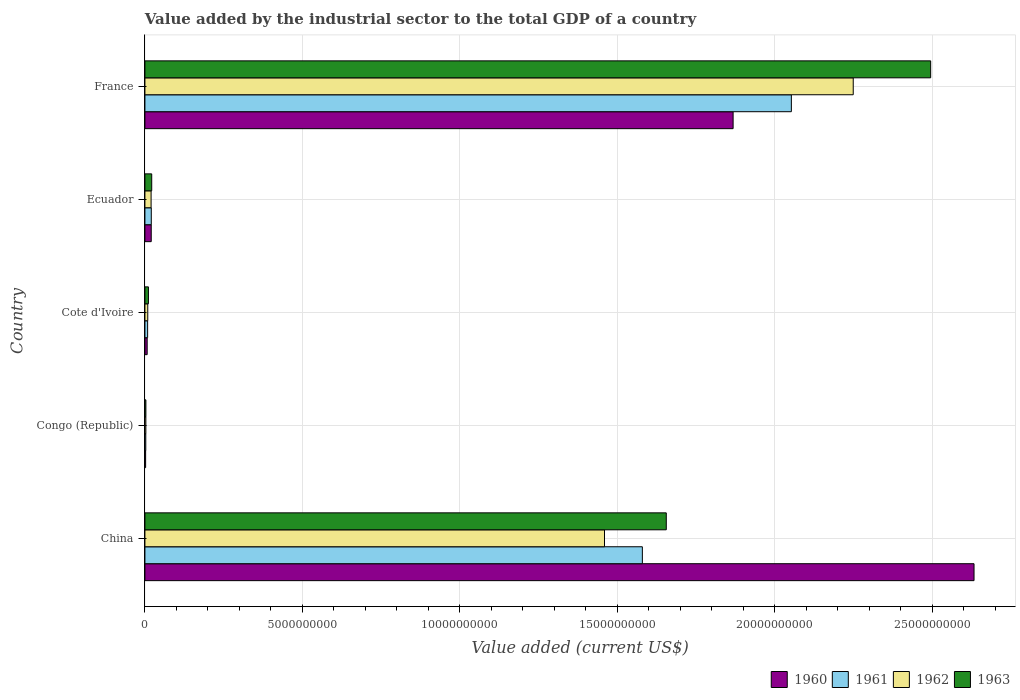How many different coloured bars are there?
Your answer should be very brief. 4. How many groups of bars are there?
Keep it short and to the point. 5. Are the number of bars per tick equal to the number of legend labels?
Your response must be concise. Yes. Are the number of bars on each tick of the Y-axis equal?
Provide a short and direct response. Yes. What is the label of the 2nd group of bars from the top?
Keep it short and to the point. Ecuador. What is the value added by the industrial sector to the total GDP in 1961 in Ecuador?
Ensure brevity in your answer.  2.02e+08. Across all countries, what is the maximum value added by the industrial sector to the total GDP in 1962?
Keep it short and to the point. 2.25e+1. Across all countries, what is the minimum value added by the industrial sector to the total GDP in 1960?
Offer a very short reply. 2.24e+07. In which country was the value added by the industrial sector to the total GDP in 1962 maximum?
Your answer should be compact. France. In which country was the value added by the industrial sector to the total GDP in 1960 minimum?
Provide a succinct answer. Congo (Republic). What is the total value added by the industrial sector to the total GDP in 1962 in the graph?
Give a very brief answer. 3.74e+1. What is the difference between the value added by the industrial sector to the total GDP in 1962 in Cote d'Ivoire and that in Ecuador?
Your answer should be very brief. -1.06e+08. What is the difference between the value added by the industrial sector to the total GDP in 1963 in France and the value added by the industrial sector to the total GDP in 1961 in China?
Ensure brevity in your answer.  9.16e+09. What is the average value added by the industrial sector to the total GDP in 1963 per country?
Provide a succinct answer. 8.37e+09. What is the difference between the value added by the industrial sector to the total GDP in 1960 and value added by the industrial sector to the total GDP in 1962 in Ecuador?
Offer a terse response. 4.47e+06. What is the ratio of the value added by the industrial sector to the total GDP in 1960 in Cote d'Ivoire to that in Ecuador?
Provide a succinct answer. 0.36. What is the difference between the highest and the second highest value added by the industrial sector to the total GDP in 1960?
Keep it short and to the point. 7.65e+09. What is the difference between the highest and the lowest value added by the industrial sector to the total GDP in 1960?
Make the answer very short. 2.63e+1. Is the sum of the value added by the industrial sector to the total GDP in 1962 in Ecuador and France greater than the maximum value added by the industrial sector to the total GDP in 1963 across all countries?
Make the answer very short. No. What does the 2nd bar from the top in Congo (Republic) represents?
Provide a short and direct response. 1962. What does the 1st bar from the bottom in China represents?
Offer a terse response. 1960. Are all the bars in the graph horizontal?
Make the answer very short. Yes. Are the values on the major ticks of X-axis written in scientific E-notation?
Provide a succinct answer. No. Where does the legend appear in the graph?
Keep it short and to the point. Bottom right. How many legend labels are there?
Your answer should be compact. 4. What is the title of the graph?
Offer a terse response. Value added by the industrial sector to the total GDP of a country. What is the label or title of the X-axis?
Provide a short and direct response. Value added (current US$). What is the label or title of the Y-axis?
Give a very brief answer. Country. What is the Value added (current US$) of 1960 in China?
Your response must be concise. 2.63e+1. What is the Value added (current US$) of 1961 in China?
Offer a terse response. 1.58e+1. What is the Value added (current US$) of 1962 in China?
Keep it short and to the point. 1.46e+1. What is the Value added (current US$) of 1963 in China?
Offer a very short reply. 1.66e+1. What is the Value added (current US$) in 1960 in Congo (Republic)?
Provide a short and direct response. 2.24e+07. What is the Value added (current US$) in 1961 in Congo (Republic)?
Your answer should be very brief. 2.73e+07. What is the Value added (current US$) of 1962 in Congo (Republic)?
Ensure brevity in your answer.  2.98e+07. What is the Value added (current US$) in 1963 in Congo (Republic)?
Provide a succinct answer. 3.06e+07. What is the Value added (current US$) in 1960 in Cote d'Ivoire?
Give a very brief answer. 7.18e+07. What is the Value added (current US$) of 1961 in Cote d'Ivoire?
Provide a short and direct response. 8.58e+07. What is the Value added (current US$) in 1962 in Cote d'Ivoire?
Offer a terse response. 9.02e+07. What is the Value added (current US$) in 1963 in Cote d'Ivoire?
Offer a terse response. 1.12e+08. What is the Value added (current US$) in 1960 in Ecuador?
Offer a terse response. 2.01e+08. What is the Value added (current US$) in 1961 in Ecuador?
Provide a short and direct response. 2.02e+08. What is the Value added (current US$) of 1962 in Ecuador?
Keep it short and to the point. 1.96e+08. What is the Value added (current US$) of 1963 in Ecuador?
Give a very brief answer. 2.16e+08. What is the Value added (current US$) in 1960 in France?
Your answer should be very brief. 1.87e+1. What is the Value added (current US$) in 1961 in France?
Your answer should be compact. 2.05e+1. What is the Value added (current US$) of 1962 in France?
Your response must be concise. 2.25e+1. What is the Value added (current US$) of 1963 in France?
Make the answer very short. 2.50e+1. Across all countries, what is the maximum Value added (current US$) of 1960?
Ensure brevity in your answer.  2.63e+1. Across all countries, what is the maximum Value added (current US$) in 1961?
Your response must be concise. 2.05e+1. Across all countries, what is the maximum Value added (current US$) of 1962?
Make the answer very short. 2.25e+1. Across all countries, what is the maximum Value added (current US$) of 1963?
Ensure brevity in your answer.  2.50e+1. Across all countries, what is the minimum Value added (current US$) in 1960?
Offer a very short reply. 2.24e+07. Across all countries, what is the minimum Value added (current US$) of 1961?
Make the answer very short. 2.73e+07. Across all countries, what is the minimum Value added (current US$) of 1962?
Give a very brief answer. 2.98e+07. Across all countries, what is the minimum Value added (current US$) in 1963?
Offer a terse response. 3.06e+07. What is the total Value added (current US$) of 1960 in the graph?
Your answer should be very brief. 4.53e+1. What is the total Value added (current US$) of 1961 in the graph?
Provide a succinct answer. 3.66e+1. What is the total Value added (current US$) in 1962 in the graph?
Your response must be concise. 3.74e+1. What is the total Value added (current US$) in 1963 in the graph?
Make the answer very short. 4.19e+1. What is the difference between the Value added (current US$) in 1960 in China and that in Congo (Republic)?
Keep it short and to the point. 2.63e+1. What is the difference between the Value added (current US$) of 1961 in China and that in Congo (Republic)?
Provide a succinct answer. 1.58e+1. What is the difference between the Value added (current US$) of 1962 in China and that in Congo (Republic)?
Ensure brevity in your answer.  1.46e+1. What is the difference between the Value added (current US$) of 1963 in China and that in Congo (Republic)?
Provide a succinct answer. 1.65e+1. What is the difference between the Value added (current US$) in 1960 in China and that in Cote d'Ivoire?
Your response must be concise. 2.63e+1. What is the difference between the Value added (current US$) of 1961 in China and that in Cote d'Ivoire?
Your answer should be very brief. 1.57e+1. What is the difference between the Value added (current US$) in 1962 in China and that in Cote d'Ivoire?
Ensure brevity in your answer.  1.45e+1. What is the difference between the Value added (current US$) in 1963 in China and that in Cote d'Ivoire?
Your answer should be compact. 1.64e+1. What is the difference between the Value added (current US$) in 1960 in China and that in Ecuador?
Keep it short and to the point. 2.61e+1. What is the difference between the Value added (current US$) of 1961 in China and that in Ecuador?
Offer a terse response. 1.56e+1. What is the difference between the Value added (current US$) of 1962 in China and that in Ecuador?
Give a very brief answer. 1.44e+1. What is the difference between the Value added (current US$) in 1963 in China and that in Ecuador?
Offer a very short reply. 1.63e+1. What is the difference between the Value added (current US$) in 1960 in China and that in France?
Ensure brevity in your answer.  7.65e+09. What is the difference between the Value added (current US$) in 1961 in China and that in France?
Provide a succinct answer. -4.73e+09. What is the difference between the Value added (current US$) in 1962 in China and that in France?
Give a very brief answer. -7.90e+09. What is the difference between the Value added (current US$) in 1963 in China and that in France?
Keep it short and to the point. -8.40e+09. What is the difference between the Value added (current US$) of 1960 in Congo (Republic) and that in Cote d'Ivoire?
Keep it short and to the point. -4.93e+07. What is the difference between the Value added (current US$) in 1961 in Congo (Republic) and that in Cote d'Ivoire?
Offer a terse response. -5.85e+07. What is the difference between the Value added (current US$) in 1962 in Congo (Republic) and that in Cote d'Ivoire?
Your answer should be compact. -6.04e+07. What is the difference between the Value added (current US$) of 1963 in Congo (Republic) and that in Cote d'Ivoire?
Your answer should be compact. -8.13e+07. What is the difference between the Value added (current US$) in 1960 in Congo (Republic) and that in Ecuador?
Provide a succinct answer. -1.78e+08. What is the difference between the Value added (current US$) in 1961 in Congo (Republic) and that in Ecuador?
Offer a terse response. -1.75e+08. What is the difference between the Value added (current US$) in 1962 in Congo (Republic) and that in Ecuador?
Give a very brief answer. -1.66e+08. What is the difference between the Value added (current US$) of 1963 in Congo (Republic) and that in Ecuador?
Provide a succinct answer. -1.85e+08. What is the difference between the Value added (current US$) of 1960 in Congo (Republic) and that in France?
Give a very brief answer. -1.87e+1. What is the difference between the Value added (current US$) of 1961 in Congo (Republic) and that in France?
Ensure brevity in your answer.  -2.05e+1. What is the difference between the Value added (current US$) in 1962 in Congo (Republic) and that in France?
Your answer should be very brief. -2.25e+1. What is the difference between the Value added (current US$) in 1963 in Congo (Republic) and that in France?
Your response must be concise. -2.49e+1. What is the difference between the Value added (current US$) of 1960 in Cote d'Ivoire and that in Ecuador?
Ensure brevity in your answer.  -1.29e+08. What is the difference between the Value added (current US$) in 1961 in Cote d'Ivoire and that in Ecuador?
Make the answer very short. -1.16e+08. What is the difference between the Value added (current US$) in 1962 in Cote d'Ivoire and that in Ecuador?
Give a very brief answer. -1.06e+08. What is the difference between the Value added (current US$) in 1963 in Cote d'Ivoire and that in Ecuador?
Give a very brief answer. -1.04e+08. What is the difference between the Value added (current US$) of 1960 in Cote d'Ivoire and that in France?
Keep it short and to the point. -1.86e+1. What is the difference between the Value added (current US$) in 1961 in Cote d'Ivoire and that in France?
Offer a terse response. -2.04e+1. What is the difference between the Value added (current US$) in 1962 in Cote d'Ivoire and that in France?
Your answer should be very brief. -2.24e+1. What is the difference between the Value added (current US$) in 1963 in Cote d'Ivoire and that in France?
Your answer should be very brief. -2.48e+1. What is the difference between the Value added (current US$) in 1960 in Ecuador and that in France?
Your response must be concise. -1.85e+1. What is the difference between the Value added (current US$) in 1961 in Ecuador and that in France?
Your response must be concise. -2.03e+1. What is the difference between the Value added (current US$) in 1962 in Ecuador and that in France?
Give a very brief answer. -2.23e+1. What is the difference between the Value added (current US$) in 1963 in Ecuador and that in France?
Ensure brevity in your answer.  -2.47e+1. What is the difference between the Value added (current US$) in 1960 in China and the Value added (current US$) in 1961 in Congo (Republic)?
Your answer should be very brief. 2.63e+1. What is the difference between the Value added (current US$) of 1960 in China and the Value added (current US$) of 1962 in Congo (Republic)?
Make the answer very short. 2.63e+1. What is the difference between the Value added (current US$) of 1960 in China and the Value added (current US$) of 1963 in Congo (Republic)?
Provide a succinct answer. 2.63e+1. What is the difference between the Value added (current US$) of 1961 in China and the Value added (current US$) of 1962 in Congo (Republic)?
Provide a succinct answer. 1.58e+1. What is the difference between the Value added (current US$) of 1961 in China and the Value added (current US$) of 1963 in Congo (Republic)?
Offer a very short reply. 1.58e+1. What is the difference between the Value added (current US$) in 1962 in China and the Value added (current US$) in 1963 in Congo (Republic)?
Your answer should be compact. 1.46e+1. What is the difference between the Value added (current US$) in 1960 in China and the Value added (current US$) in 1961 in Cote d'Ivoire?
Offer a terse response. 2.62e+1. What is the difference between the Value added (current US$) of 1960 in China and the Value added (current US$) of 1962 in Cote d'Ivoire?
Your response must be concise. 2.62e+1. What is the difference between the Value added (current US$) in 1960 in China and the Value added (current US$) in 1963 in Cote d'Ivoire?
Your response must be concise. 2.62e+1. What is the difference between the Value added (current US$) of 1961 in China and the Value added (current US$) of 1962 in Cote d'Ivoire?
Make the answer very short. 1.57e+1. What is the difference between the Value added (current US$) of 1961 in China and the Value added (current US$) of 1963 in Cote d'Ivoire?
Provide a short and direct response. 1.57e+1. What is the difference between the Value added (current US$) in 1962 in China and the Value added (current US$) in 1963 in Cote d'Ivoire?
Your response must be concise. 1.45e+1. What is the difference between the Value added (current US$) of 1960 in China and the Value added (current US$) of 1961 in Ecuador?
Provide a succinct answer. 2.61e+1. What is the difference between the Value added (current US$) of 1960 in China and the Value added (current US$) of 1962 in Ecuador?
Give a very brief answer. 2.61e+1. What is the difference between the Value added (current US$) in 1960 in China and the Value added (current US$) in 1963 in Ecuador?
Give a very brief answer. 2.61e+1. What is the difference between the Value added (current US$) of 1961 in China and the Value added (current US$) of 1962 in Ecuador?
Give a very brief answer. 1.56e+1. What is the difference between the Value added (current US$) in 1961 in China and the Value added (current US$) in 1963 in Ecuador?
Ensure brevity in your answer.  1.56e+1. What is the difference between the Value added (current US$) of 1962 in China and the Value added (current US$) of 1963 in Ecuador?
Make the answer very short. 1.44e+1. What is the difference between the Value added (current US$) in 1960 in China and the Value added (current US$) in 1961 in France?
Make the answer very short. 5.80e+09. What is the difference between the Value added (current US$) in 1960 in China and the Value added (current US$) in 1962 in France?
Provide a succinct answer. 3.84e+09. What is the difference between the Value added (current US$) of 1960 in China and the Value added (current US$) of 1963 in France?
Your answer should be very brief. 1.38e+09. What is the difference between the Value added (current US$) of 1961 in China and the Value added (current US$) of 1962 in France?
Your answer should be compact. -6.70e+09. What is the difference between the Value added (current US$) of 1961 in China and the Value added (current US$) of 1963 in France?
Make the answer very short. -9.16e+09. What is the difference between the Value added (current US$) of 1962 in China and the Value added (current US$) of 1963 in France?
Offer a terse response. -1.04e+1. What is the difference between the Value added (current US$) in 1960 in Congo (Republic) and the Value added (current US$) in 1961 in Cote d'Ivoire?
Provide a succinct answer. -6.34e+07. What is the difference between the Value added (current US$) of 1960 in Congo (Republic) and the Value added (current US$) of 1962 in Cote d'Ivoire?
Keep it short and to the point. -6.78e+07. What is the difference between the Value added (current US$) of 1960 in Congo (Republic) and the Value added (current US$) of 1963 in Cote d'Ivoire?
Your response must be concise. -8.94e+07. What is the difference between the Value added (current US$) in 1961 in Congo (Republic) and the Value added (current US$) in 1962 in Cote d'Ivoire?
Give a very brief answer. -6.29e+07. What is the difference between the Value added (current US$) in 1961 in Congo (Republic) and the Value added (current US$) in 1963 in Cote d'Ivoire?
Offer a terse response. -8.46e+07. What is the difference between the Value added (current US$) of 1962 in Congo (Republic) and the Value added (current US$) of 1963 in Cote d'Ivoire?
Make the answer very short. -8.21e+07. What is the difference between the Value added (current US$) of 1960 in Congo (Republic) and the Value added (current US$) of 1961 in Ecuador?
Offer a terse response. -1.80e+08. What is the difference between the Value added (current US$) of 1960 in Congo (Republic) and the Value added (current US$) of 1962 in Ecuador?
Keep it short and to the point. -1.74e+08. What is the difference between the Value added (current US$) in 1960 in Congo (Republic) and the Value added (current US$) in 1963 in Ecuador?
Your response must be concise. -1.94e+08. What is the difference between the Value added (current US$) in 1961 in Congo (Republic) and the Value added (current US$) in 1962 in Ecuador?
Keep it short and to the point. -1.69e+08. What is the difference between the Value added (current US$) of 1961 in Congo (Republic) and the Value added (current US$) of 1963 in Ecuador?
Give a very brief answer. -1.89e+08. What is the difference between the Value added (current US$) of 1962 in Congo (Republic) and the Value added (current US$) of 1963 in Ecuador?
Offer a terse response. -1.86e+08. What is the difference between the Value added (current US$) in 1960 in Congo (Republic) and the Value added (current US$) in 1961 in France?
Keep it short and to the point. -2.05e+1. What is the difference between the Value added (current US$) in 1960 in Congo (Republic) and the Value added (current US$) in 1962 in France?
Make the answer very short. -2.25e+1. What is the difference between the Value added (current US$) of 1960 in Congo (Republic) and the Value added (current US$) of 1963 in France?
Your response must be concise. -2.49e+1. What is the difference between the Value added (current US$) in 1961 in Congo (Republic) and the Value added (current US$) in 1962 in France?
Offer a terse response. -2.25e+1. What is the difference between the Value added (current US$) in 1961 in Congo (Republic) and the Value added (current US$) in 1963 in France?
Provide a short and direct response. -2.49e+1. What is the difference between the Value added (current US$) of 1962 in Congo (Republic) and the Value added (current US$) of 1963 in France?
Your answer should be very brief. -2.49e+1. What is the difference between the Value added (current US$) in 1960 in Cote d'Ivoire and the Value added (current US$) in 1961 in Ecuador?
Ensure brevity in your answer.  -1.30e+08. What is the difference between the Value added (current US$) of 1960 in Cote d'Ivoire and the Value added (current US$) of 1962 in Ecuador?
Provide a succinct answer. -1.24e+08. What is the difference between the Value added (current US$) in 1960 in Cote d'Ivoire and the Value added (current US$) in 1963 in Ecuador?
Provide a succinct answer. -1.44e+08. What is the difference between the Value added (current US$) of 1961 in Cote d'Ivoire and the Value added (current US$) of 1962 in Ecuador?
Your answer should be very brief. -1.10e+08. What is the difference between the Value added (current US$) in 1961 in Cote d'Ivoire and the Value added (current US$) in 1963 in Ecuador?
Provide a succinct answer. -1.30e+08. What is the difference between the Value added (current US$) of 1962 in Cote d'Ivoire and the Value added (current US$) of 1963 in Ecuador?
Give a very brief answer. -1.26e+08. What is the difference between the Value added (current US$) of 1960 in Cote d'Ivoire and the Value added (current US$) of 1961 in France?
Provide a short and direct response. -2.05e+1. What is the difference between the Value added (current US$) in 1960 in Cote d'Ivoire and the Value added (current US$) in 1962 in France?
Make the answer very short. -2.24e+1. What is the difference between the Value added (current US$) of 1960 in Cote d'Ivoire and the Value added (current US$) of 1963 in France?
Provide a short and direct response. -2.49e+1. What is the difference between the Value added (current US$) of 1961 in Cote d'Ivoire and the Value added (current US$) of 1962 in France?
Give a very brief answer. -2.24e+1. What is the difference between the Value added (current US$) of 1961 in Cote d'Ivoire and the Value added (current US$) of 1963 in France?
Make the answer very short. -2.49e+1. What is the difference between the Value added (current US$) of 1962 in Cote d'Ivoire and the Value added (current US$) of 1963 in France?
Keep it short and to the point. -2.49e+1. What is the difference between the Value added (current US$) of 1960 in Ecuador and the Value added (current US$) of 1961 in France?
Keep it short and to the point. -2.03e+1. What is the difference between the Value added (current US$) of 1960 in Ecuador and the Value added (current US$) of 1962 in France?
Your answer should be very brief. -2.23e+1. What is the difference between the Value added (current US$) in 1960 in Ecuador and the Value added (current US$) in 1963 in France?
Offer a very short reply. -2.48e+1. What is the difference between the Value added (current US$) in 1961 in Ecuador and the Value added (current US$) in 1962 in France?
Make the answer very short. -2.23e+1. What is the difference between the Value added (current US$) of 1961 in Ecuador and the Value added (current US$) of 1963 in France?
Your response must be concise. -2.48e+1. What is the difference between the Value added (current US$) of 1962 in Ecuador and the Value added (current US$) of 1963 in France?
Your answer should be compact. -2.48e+1. What is the average Value added (current US$) in 1960 per country?
Make the answer very short. 9.06e+09. What is the average Value added (current US$) in 1961 per country?
Your response must be concise. 7.33e+09. What is the average Value added (current US$) in 1962 per country?
Make the answer very short. 7.48e+09. What is the average Value added (current US$) of 1963 per country?
Ensure brevity in your answer.  8.37e+09. What is the difference between the Value added (current US$) of 1960 and Value added (current US$) of 1961 in China?
Provide a succinct answer. 1.05e+1. What is the difference between the Value added (current US$) in 1960 and Value added (current US$) in 1962 in China?
Provide a succinct answer. 1.17e+1. What is the difference between the Value added (current US$) in 1960 and Value added (current US$) in 1963 in China?
Provide a succinct answer. 9.77e+09. What is the difference between the Value added (current US$) of 1961 and Value added (current US$) of 1962 in China?
Your answer should be compact. 1.20e+09. What is the difference between the Value added (current US$) in 1961 and Value added (current US$) in 1963 in China?
Provide a short and direct response. -7.60e+08. What is the difference between the Value added (current US$) of 1962 and Value added (current US$) of 1963 in China?
Offer a terse response. -1.96e+09. What is the difference between the Value added (current US$) in 1960 and Value added (current US$) in 1961 in Congo (Republic)?
Make the answer very short. -4.89e+06. What is the difference between the Value added (current US$) of 1960 and Value added (current US$) of 1962 in Congo (Republic)?
Your answer should be very brief. -7.36e+06. What is the difference between the Value added (current US$) in 1960 and Value added (current US$) in 1963 in Congo (Republic)?
Make the answer very short. -8.18e+06. What is the difference between the Value added (current US$) of 1961 and Value added (current US$) of 1962 in Congo (Republic)?
Provide a short and direct response. -2.48e+06. What is the difference between the Value added (current US$) in 1961 and Value added (current US$) in 1963 in Congo (Republic)?
Offer a very short reply. -3.29e+06. What is the difference between the Value added (current US$) of 1962 and Value added (current US$) of 1963 in Congo (Republic)?
Your response must be concise. -8.16e+05. What is the difference between the Value added (current US$) of 1960 and Value added (current US$) of 1961 in Cote d'Ivoire?
Provide a succinct answer. -1.40e+07. What is the difference between the Value added (current US$) of 1960 and Value added (current US$) of 1962 in Cote d'Ivoire?
Your response must be concise. -1.85e+07. What is the difference between the Value added (current US$) in 1960 and Value added (current US$) in 1963 in Cote d'Ivoire?
Ensure brevity in your answer.  -4.01e+07. What is the difference between the Value added (current US$) of 1961 and Value added (current US$) of 1962 in Cote d'Ivoire?
Give a very brief answer. -4.42e+06. What is the difference between the Value added (current US$) in 1961 and Value added (current US$) in 1963 in Cote d'Ivoire?
Give a very brief answer. -2.61e+07. What is the difference between the Value added (current US$) of 1962 and Value added (current US$) of 1963 in Cote d'Ivoire?
Your answer should be very brief. -2.17e+07. What is the difference between the Value added (current US$) of 1960 and Value added (current US$) of 1961 in Ecuador?
Provide a succinct answer. -1.51e+06. What is the difference between the Value added (current US$) of 1960 and Value added (current US$) of 1962 in Ecuador?
Give a very brief answer. 4.47e+06. What is the difference between the Value added (current US$) of 1960 and Value added (current US$) of 1963 in Ecuador?
Provide a succinct answer. -1.55e+07. What is the difference between the Value added (current US$) in 1961 and Value added (current US$) in 1962 in Ecuador?
Offer a terse response. 5.98e+06. What is the difference between the Value added (current US$) of 1961 and Value added (current US$) of 1963 in Ecuador?
Provide a short and direct response. -1.39e+07. What is the difference between the Value added (current US$) in 1962 and Value added (current US$) in 1963 in Ecuador?
Your response must be concise. -1.99e+07. What is the difference between the Value added (current US$) in 1960 and Value added (current US$) in 1961 in France?
Make the answer very short. -1.85e+09. What is the difference between the Value added (current US$) of 1960 and Value added (current US$) of 1962 in France?
Provide a short and direct response. -3.81e+09. What is the difference between the Value added (current US$) of 1960 and Value added (current US$) of 1963 in France?
Your answer should be very brief. -6.27e+09. What is the difference between the Value added (current US$) of 1961 and Value added (current US$) of 1962 in France?
Your response must be concise. -1.97e+09. What is the difference between the Value added (current US$) of 1961 and Value added (current US$) of 1963 in France?
Provide a succinct answer. -4.42e+09. What is the difference between the Value added (current US$) in 1962 and Value added (current US$) in 1963 in France?
Offer a very short reply. -2.46e+09. What is the ratio of the Value added (current US$) of 1960 in China to that in Congo (Republic)?
Offer a terse response. 1173.83. What is the ratio of the Value added (current US$) in 1961 in China to that in Congo (Republic)?
Your answer should be compact. 578.28. What is the ratio of the Value added (current US$) in 1962 in China to that in Congo (Republic)?
Make the answer very short. 489.86. What is the ratio of the Value added (current US$) in 1963 in China to that in Congo (Republic)?
Provide a short and direct response. 540.9. What is the ratio of the Value added (current US$) of 1960 in China to that in Cote d'Ivoire?
Your answer should be compact. 366.9. What is the ratio of the Value added (current US$) in 1961 in China to that in Cote d'Ivoire?
Your response must be concise. 184.1. What is the ratio of the Value added (current US$) in 1962 in China to that in Cote d'Ivoire?
Your response must be concise. 161.77. What is the ratio of the Value added (current US$) in 1963 in China to that in Cote d'Ivoire?
Provide a succinct answer. 147.99. What is the ratio of the Value added (current US$) of 1960 in China to that in Ecuador?
Offer a terse response. 131.22. What is the ratio of the Value added (current US$) in 1961 in China to that in Ecuador?
Keep it short and to the point. 78.14. What is the ratio of the Value added (current US$) of 1962 in China to that in Ecuador?
Give a very brief answer. 74.39. What is the ratio of the Value added (current US$) in 1963 in China to that in Ecuador?
Provide a short and direct response. 76.62. What is the ratio of the Value added (current US$) in 1960 in China to that in France?
Your answer should be compact. 1.41. What is the ratio of the Value added (current US$) of 1961 in China to that in France?
Your response must be concise. 0.77. What is the ratio of the Value added (current US$) in 1962 in China to that in France?
Your answer should be compact. 0.65. What is the ratio of the Value added (current US$) of 1963 in China to that in France?
Give a very brief answer. 0.66. What is the ratio of the Value added (current US$) in 1960 in Congo (Republic) to that in Cote d'Ivoire?
Offer a terse response. 0.31. What is the ratio of the Value added (current US$) of 1961 in Congo (Republic) to that in Cote d'Ivoire?
Offer a terse response. 0.32. What is the ratio of the Value added (current US$) of 1962 in Congo (Republic) to that in Cote d'Ivoire?
Your answer should be compact. 0.33. What is the ratio of the Value added (current US$) of 1963 in Congo (Republic) to that in Cote d'Ivoire?
Give a very brief answer. 0.27. What is the ratio of the Value added (current US$) in 1960 in Congo (Republic) to that in Ecuador?
Give a very brief answer. 0.11. What is the ratio of the Value added (current US$) in 1961 in Congo (Republic) to that in Ecuador?
Provide a short and direct response. 0.14. What is the ratio of the Value added (current US$) in 1962 in Congo (Republic) to that in Ecuador?
Offer a terse response. 0.15. What is the ratio of the Value added (current US$) of 1963 in Congo (Republic) to that in Ecuador?
Ensure brevity in your answer.  0.14. What is the ratio of the Value added (current US$) of 1960 in Congo (Republic) to that in France?
Offer a terse response. 0. What is the ratio of the Value added (current US$) of 1961 in Congo (Republic) to that in France?
Make the answer very short. 0. What is the ratio of the Value added (current US$) of 1962 in Congo (Republic) to that in France?
Offer a very short reply. 0. What is the ratio of the Value added (current US$) of 1963 in Congo (Republic) to that in France?
Ensure brevity in your answer.  0. What is the ratio of the Value added (current US$) of 1960 in Cote d'Ivoire to that in Ecuador?
Your answer should be very brief. 0.36. What is the ratio of the Value added (current US$) in 1961 in Cote d'Ivoire to that in Ecuador?
Offer a terse response. 0.42. What is the ratio of the Value added (current US$) of 1962 in Cote d'Ivoire to that in Ecuador?
Your response must be concise. 0.46. What is the ratio of the Value added (current US$) in 1963 in Cote d'Ivoire to that in Ecuador?
Offer a terse response. 0.52. What is the ratio of the Value added (current US$) of 1960 in Cote d'Ivoire to that in France?
Keep it short and to the point. 0. What is the ratio of the Value added (current US$) of 1961 in Cote d'Ivoire to that in France?
Your response must be concise. 0. What is the ratio of the Value added (current US$) in 1962 in Cote d'Ivoire to that in France?
Offer a very short reply. 0. What is the ratio of the Value added (current US$) of 1963 in Cote d'Ivoire to that in France?
Offer a very short reply. 0. What is the ratio of the Value added (current US$) in 1960 in Ecuador to that in France?
Your answer should be compact. 0.01. What is the ratio of the Value added (current US$) of 1961 in Ecuador to that in France?
Offer a very short reply. 0.01. What is the ratio of the Value added (current US$) of 1962 in Ecuador to that in France?
Your answer should be compact. 0.01. What is the ratio of the Value added (current US$) in 1963 in Ecuador to that in France?
Your answer should be compact. 0.01. What is the difference between the highest and the second highest Value added (current US$) of 1960?
Provide a short and direct response. 7.65e+09. What is the difference between the highest and the second highest Value added (current US$) in 1961?
Provide a short and direct response. 4.73e+09. What is the difference between the highest and the second highest Value added (current US$) of 1962?
Your answer should be very brief. 7.90e+09. What is the difference between the highest and the second highest Value added (current US$) of 1963?
Your response must be concise. 8.40e+09. What is the difference between the highest and the lowest Value added (current US$) in 1960?
Make the answer very short. 2.63e+1. What is the difference between the highest and the lowest Value added (current US$) of 1961?
Offer a very short reply. 2.05e+1. What is the difference between the highest and the lowest Value added (current US$) in 1962?
Offer a terse response. 2.25e+1. What is the difference between the highest and the lowest Value added (current US$) in 1963?
Offer a terse response. 2.49e+1. 